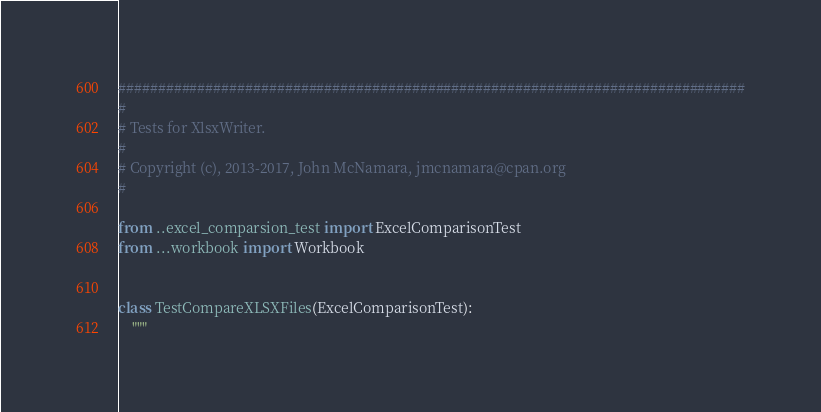<code> <loc_0><loc_0><loc_500><loc_500><_Python_>###############################################################################
#
# Tests for XlsxWriter.
#
# Copyright (c), 2013-2017, John McNamara, jmcnamara@cpan.org
#

from ..excel_comparsion_test import ExcelComparisonTest
from ...workbook import Workbook


class TestCompareXLSXFiles(ExcelComparisonTest):
    """</code> 